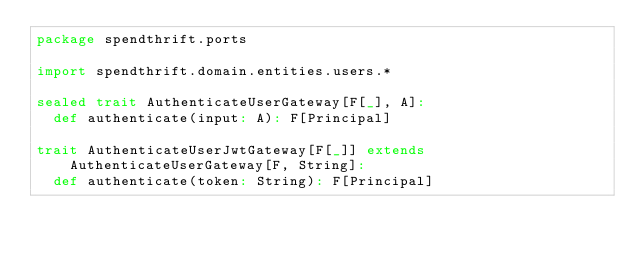<code> <loc_0><loc_0><loc_500><loc_500><_Scala_>package spendthrift.ports

import spendthrift.domain.entities.users.*

sealed trait AuthenticateUserGateway[F[_], A]:
  def authenticate(input: A): F[Principal]

trait AuthenticateUserJwtGateway[F[_]] extends AuthenticateUserGateway[F, String]:
  def authenticate(token: String): F[Principal]
</code> 